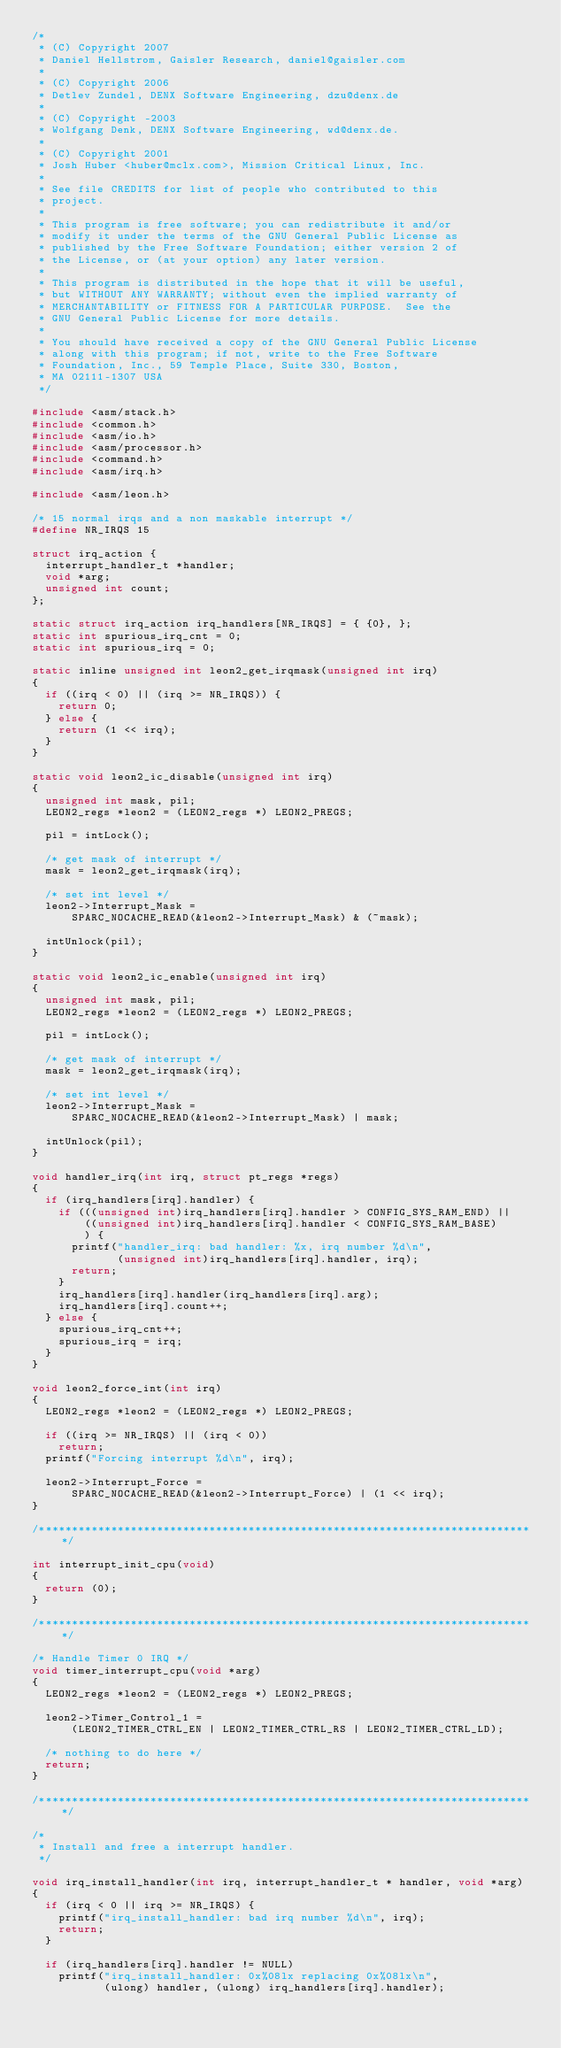Convert code to text. <code><loc_0><loc_0><loc_500><loc_500><_C_>/*
 * (C) Copyright 2007
 * Daniel Hellstrom, Gaisler Research, daniel@gaisler.com
 *
 * (C) Copyright 2006
 * Detlev Zundel, DENX Software Engineering, dzu@denx.de
 *
 * (C) Copyright -2003
 * Wolfgang Denk, DENX Software Engineering, wd@denx.de.
 *
 * (C) Copyright 2001
 * Josh Huber <huber@mclx.com>, Mission Critical Linux, Inc.
 *
 * See file CREDITS for list of people who contributed to this
 * project.
 *
 * This program is free software; you can redistribute it and/or
 * modify it under the terms of the GNU General Public License as
 * published by the Free Software Foundation; either version 2 of
 * the License, or (at your option) any later version.
 *
 * This program is distributed in the hope that it will be useful,
 * but WITHOUT ANY WARRANTY; without even the implied warranty of
 * MERCHANTABILITY or FITNESS FOR A PARTICULAR PURPOSE.  See the
 * GNU General Public License for more details.
 *
 * You should have received a copy of the GNU General Public License
 * along with this program; if not, write to the Free Software
 * Foundation, Inc., 59 Temple Place, Suite 330, Boston,
 * MA 02111-1307 USA
 */

#include <asm/stack.h>
#include <common.h>
#include <asm/io.h>
#include <asm/processor.h>
#include <command.h>
#include <asm/irq.h>

#include <asm/leon.h>

/* 15 normal irqs and a non maskable interrupt */
#define NR_IRQS 15

struct irq_action {
	interrupt_handler_t *handler;
	void *arg;
	unsigned int count;
};

static struct irq_action irq_handlers[NR_IRQS] = { {0}, };
static int spurious_irq_cnt = 0;
static int spurious_irq = 0;

static inline unsigned int leon2_get_irqmask(unsigned int irq)
{
	if ((irq < 0) || (irq >= NR_IRQS)) {
		return 0;
	} else {
		return (1 << irq);
	}
}

static void leon2_ic_disable(unsigned int irq)
{
	unsigned int mask, pil;
	LEON2_regs *leon2 = (LEON2_regs *) LEON2_PREGS;

	pil = intLock();

	/* get mask of interrupt */
	mask = leon2_get_irqmask(irq);

	/* set int level */
	leon2->Interrupt_Mask =
	    SPARC_NOCACHE_READ(&leon2->Interrupt_Mask) & (~mask);

	intUnlock(pil);
}

static void leon2_ic_enable(unsigned int irq)
{
	unsigned int mask, pil;
	LEON2_regs *leon2 = (LEON2_regs *) LEON2_PREGS;

	pil = intLock();

	/* get mask of interrupt */
	mask = leon2_get_irqmask(irq);

	/* set int level */
	leon2->Interrupt_Mask =
	    SPARC_NOCACHE_READ(&leon2->Interrupt_Mask) | mask;

	intUnlock(pil);
}

void handler_irq(int irq, struct pt_regs *regs)
{
	if (irq_handlers[irq].handler) {
		if (((unsigned int)irq_handlers[irq].handler > CONFIG_SYS_RAM_END) ||
		    ((unsigned int)irq_handlers[irq].handler < CONFIG_SYS_RAM_BASE)
		    ) {
			printf("handler_irq: bad handler: %x, irq number %d\n",
			       (unsigned int)irq_handlers[irq].handler, irq);
			return;
		}
		irq_handlers[irq].handler(irq_handlers[irq].arg);
		irq_handlers[irq].count++;
	} else {
		spurious_irq_cnt++;
		spurious_irq = irq;
	}
}

void leon2_force_int(int irq)
{
	LEON2_regs *leon2 = (LEON2_regs *) LEON2_PREGS;

	if ((irq >= NR_IRQS) || (irq < 0))
		return;
	printf("Forcing interrupt %d\n", irq);

	leon2->Interrupt_Force =
	    SPARC_NOCACHE_READ(&leon2->Interrupt_Force) | (1 << irq);
}

/****************************************************************************/

int interrupt_init_cpu(void)
{
	return (0);
}

/****************************************************************************/

/* Handle Timer 0 IRQ */
void timer_interrupt_cpu(void *arg)
{
	LEON2_regs *leon2 = (LEON2_regs *) LEON2_PREGS;

	leon2->Timer_Control_1 =
	    (LEON2_TIMER_CTRL_EN | LEON2_TIMER_CTRL_RS | LEON2_TIMER_CTRL_LD);

	/* nothing to do here */
	return;
}

/****************************************************************************/

/*
 * Install and free a interrupt handler.
 */

void irq_install_handler(int irq, interrupt_handler_t * handler, void *arg)
{
	if (irq < 0 || irq >= NR_IRQS) {
		printf("irq_install_handler: bad irq number %d\n", irq);
		return;
	}

	if (irq_handlers[irq].handler != NULL)
		printf("irq_install_handler: 0x%08lx replacing 0x%08lx\n",
		       (ulong) handler, (ulong) irq_handlers[irq].handler);
</code> 